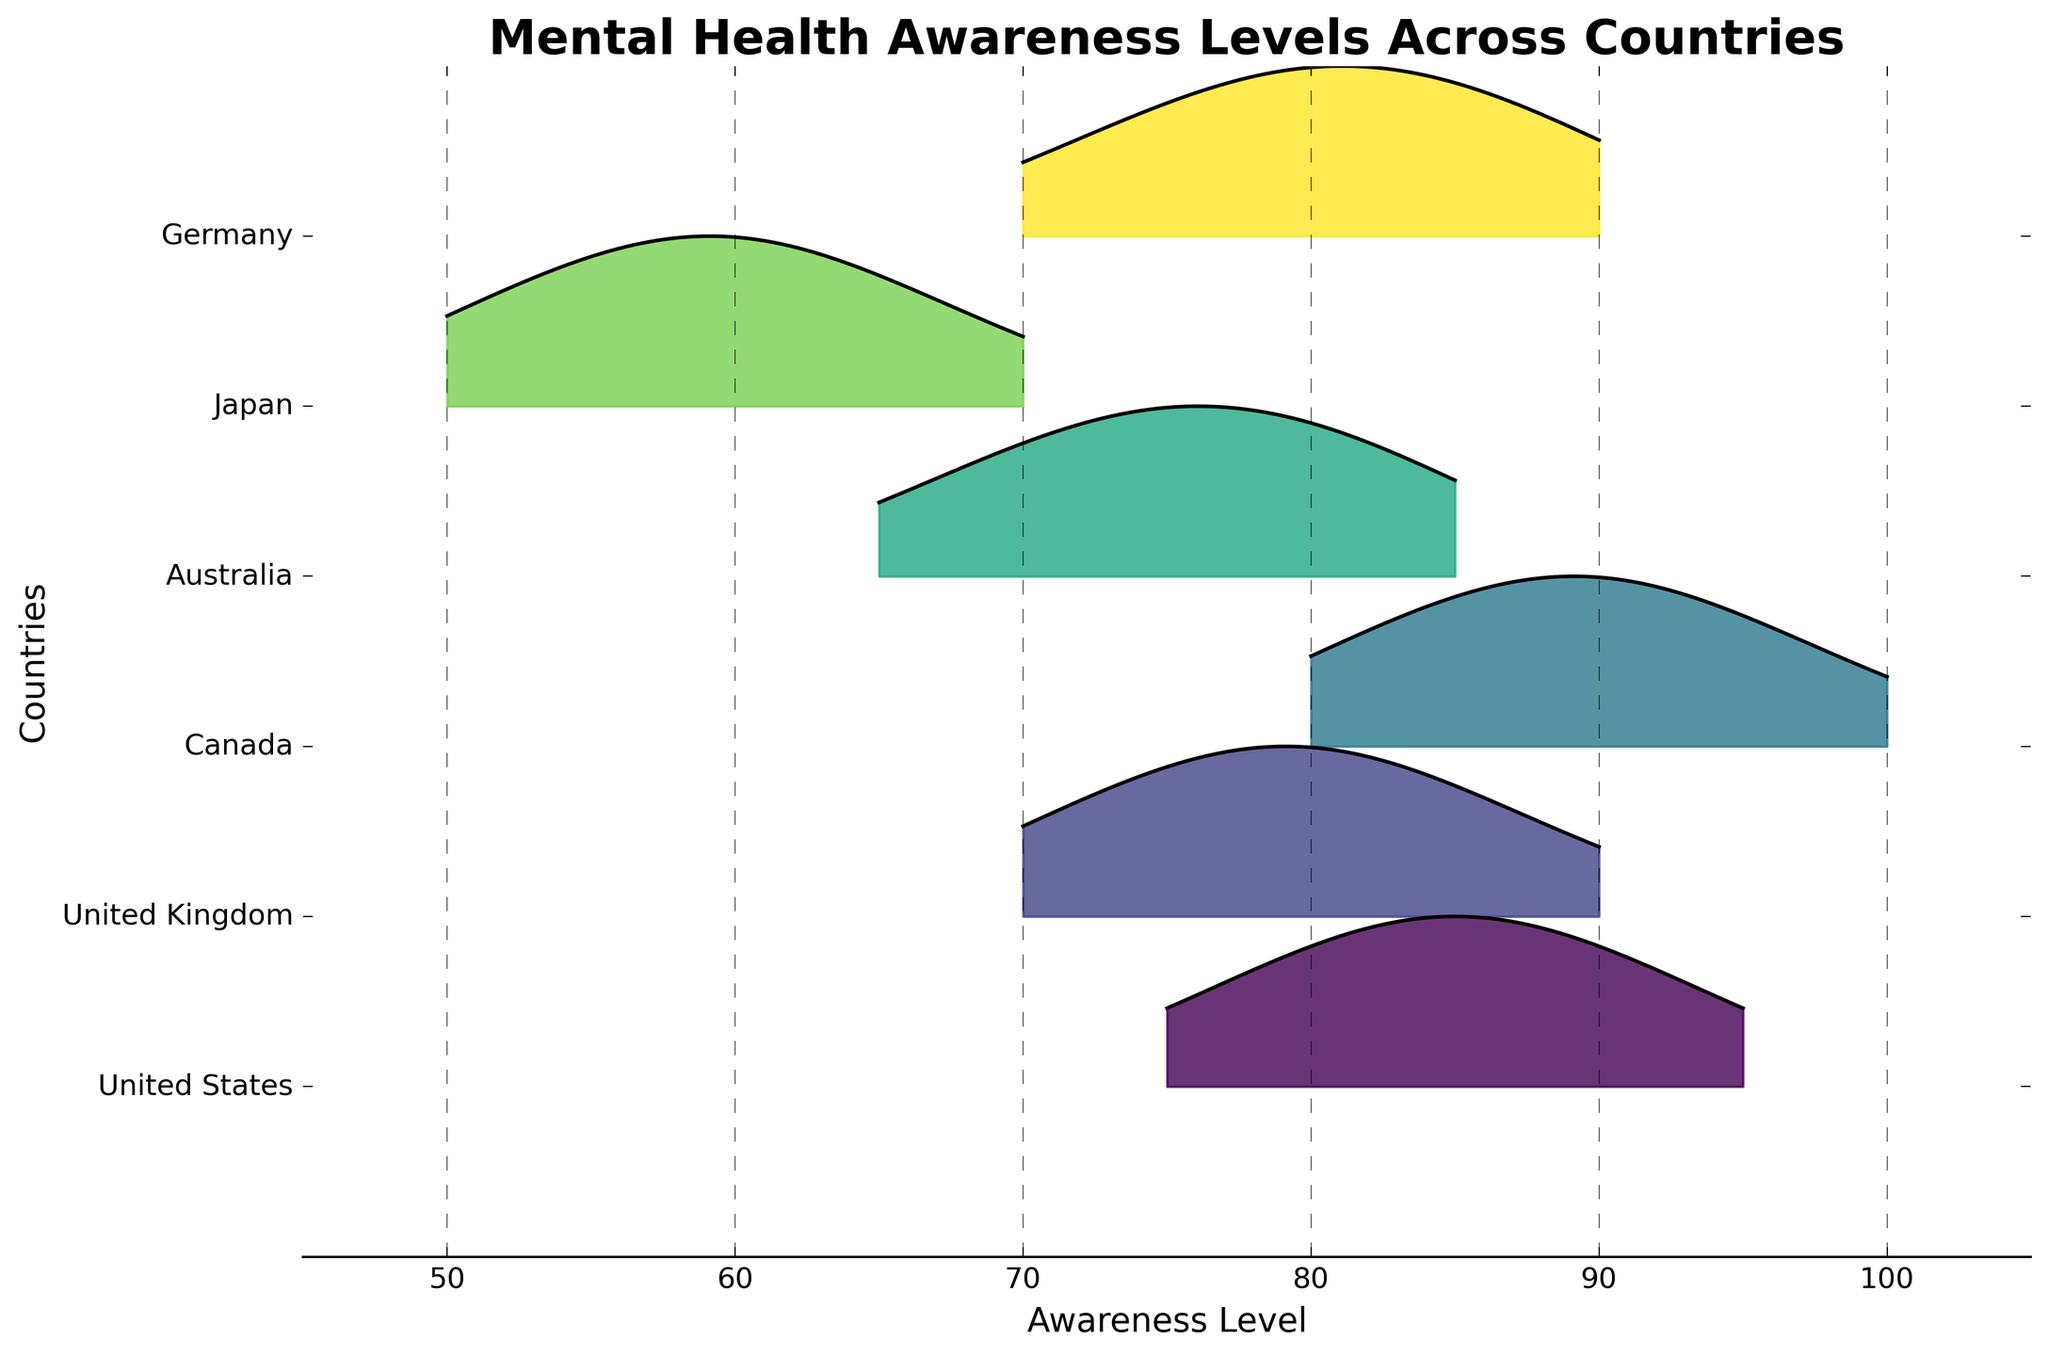What is the title of the plot? The title is often placed at the top of the plot and gives a brief description of what the plot represents. By looking at the top of the plot, we can see it clearly says "Mental Health Awareness Levels Across Countries".
Answer: Mental Health Awareness Levels Across Countries What are the x-axis and y-axis labels? Axis labels provide context to the data being plotted. The x-axis label is found below the horizontal axis and states "Awareness Level", while the y-axis label is to the left of the vertical axis and states "Countries".
Answer: x-axis: Awareness Level, y-axis: Countries Which country appears to have the highest peak in mental health awareness levels? To determine this, we compare the height of the ridges for each country on the plot. The highest peak appears to be Canada around an awareness level of 90-95.
Answer: Canada How do awareness levels in Japan compare to those in the United States? Observing the ridges, Japan has lower awareness levels peaking around 60-65, significantly lower than the United States, which peaks around 85-90. Thus, the awareness levels in Japan are lower compared to the United States.
Answer: Lower Which country shows the widest range of awareness levels? The range can be assessed by looking at the spread of the ridgeline for each country from the minimum to maximum awareness levels. Australia shows a wide range from 65 to 85 while others show narrower peaks.
Answer: Australia How many distinct awareness level peaks are visible for the United Kingdom? Peaks represent high points in the frequency at various awareness levels. For the United Kingdom, there are distinct peaks at 70, 75, and 80.
Answer: 3 peaks What is the awareness level with the highest frequency for Germany? By looking at the plot for Germany, the highest point (peak) in the ridgeline appears around the awareness level of 80.
Answer: 80 Which countries have their highest awareness levels around 85? We need to identify ridgelines with peaks around the 85 mark. Both the United States and Germany appear to have significant peaks near 85.
Answer: United States and Germany What's the combined range of awareness levels for Canada and Australia? First, identify the minimum and maximum awareness levels for both countries: Canada (80-100) and Australia (65-85). Then combine the ranges to get the overall range. The combined range is from the lowest minimum to the highest maximum, 65 to 100.
Answer: 65 to 100 In which country is the awareness level density more evenly distributed across the different levels? Areas under the ridgeline that are more evenly spread indicate a more uniform distribution. The United Kingdom and Germany show more evenly spread peaks compared to others.
Answer: United Kingdom and Germany 